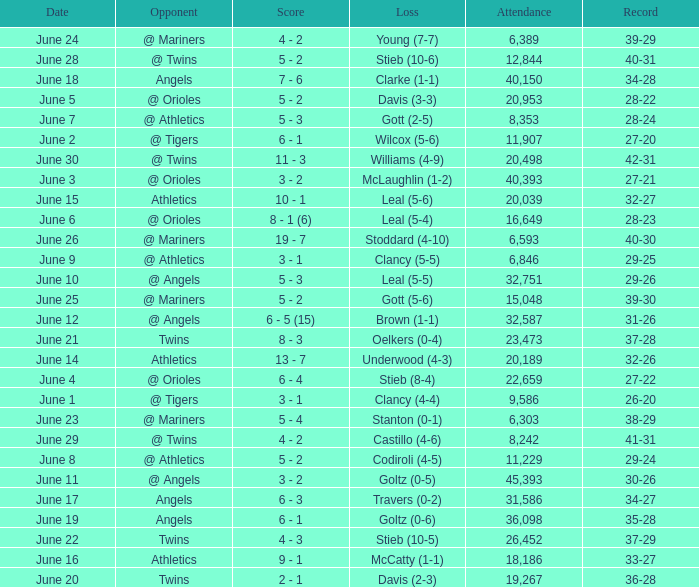What was the record for the date of June 14? 32-26. Would you mind parsing the complete table? {'header': ['Date', 'Opponent', 'Score', 'Loss', 'Attendance', 'Record'], 'rows': [['June 24', '@ Mariners', '4 - 2', 'Young (7-7)', '6,389', '39-29'], ['June 28', '@ Twins', '5 - 2', 'Stieb (10-6)', '12,844', '40-31'], ['June 18', 'Angels', '7 - 6', 'Clarke (1-1)', '40,150', '34-28'], ['June 5', '@ Orioles', '5 - 2', 'Davis (3-3)', '20,953', '28-22'], ['June 7', '@ Athletics', '5 - 3', 'Gott (2-5)', '8,353', '28-24'], ['June 2', '@ Tigers', '6 - 1', 'Wilcox (5-6)', '11,907', '27-20'], ['June 30', '@ Twins', '11 - 3', 'Williams (4-9)', '20,498', '42-31'], ['June 3', '@ Orioles', '3 - 2', 'McLaughlin (1-2)', '40,393', '27-21'], ['June 15', 'Athletics', '10 - 1', 'Leal (5-6)', '20,039', '32-27'], ['June 6', '@ Orioles', '8 - 1 (6)', 'Leal (5-4)', '16,649', '28-23'], ['June 26', '@ Mariners', '19 - 7', 'Stoddard (4-10)', '6,593', '40-30'], ['June 9', '@ Athletics', '3 - 1', 'Clancy (5-5)', '6,846', '29-25'], ['June 10', '@ Angels', '5 - 3', 'Leal (5-5)', '32,751', '29-26'], ['June 25', '@ Mariners', '5 - 2', 'Gott (5-6)', '15,048', '39-30'], ['June 12', '@ Angels', '6 - 5 (15)', 'Brown (1-1)', '32,587', '31-26'], ['June 21', 'Twins', '8 - 3', 'Oelkers (0-4)', '23,473', '37-28'], ['June 14', 'Athletics', '13 - 7', 'Underwood (4-3)', '20,189', '32-26'], ['June 4', '@ Orioles', '6 - 4', 'Stieb (8-4)', '22,659', '27-22'], ['June 1', '@ Tigers', '3 - 1', 'Clancy (4-4)', '9,586', '26-20'], ['June 23', '@ Mariners', '5 - 4', 'Stanton (0-1)', '6,303', '38-29'], ['June 29', '@ Twins', '4 - 2', 'Castillo (4-6)', '8,242', '41-31'], ['June 8', '@ Athletics', '5 - 2', 'Codiroli (4-5)', '11,229', '29-24'], ['June 11', '@ Angels', '3 - 2', 'Goltz (0-5)', '45,393', '30-26'], ['June 17', 'Angels', '6 - 3', 'Travers (0-2)', '31,586', '34-27'], ['June 19', 'Angels', '6 - 1', 'Goltz (0-6)', '36,098', '35-28'], ['June 22', 'Twins', '4 - 3', 'Stieb (10-5)', '26,452', '37-29'], ['June 16', 'Athletics', '9 - 1', 'McCatty (1-1)', '18,186', '33-27'], ['June 20', 'Twins', '2 - 1', 'Davis (2-3)', '19,267', '36-28']]} 